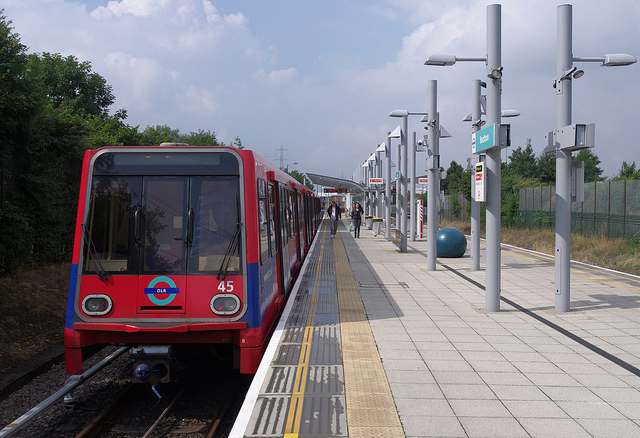<image>Where is the trolley getting power? It is uncertain where the trolley is getting power, but it might be from the tracks or an engine. Where is the trolley getting power? I am not sure where the trolley is getting power. It can be getting power from the rails, track or electricity. 